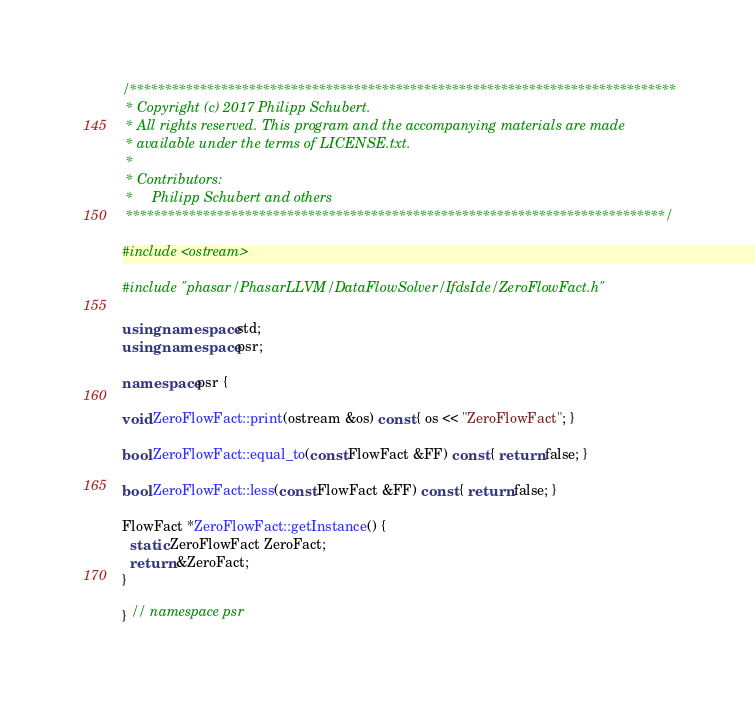Convert code to text. <code><loc_0><loc_0><loc_500><loc_500><_C++_>/******************************************************************************
 * Copyright (c) 2017 Philipp Schubert.
 * All rights reserved. This program and the accompanying materials are made
 * available under the terms of LICENSE.txt.
 *
 * Contributors:
 *     Philipp Schubert and others
 *****************************************************************************/

#include <ostream>

#include "phasar/PhasarLLVM/DataFlowSolver/IfdsIde/ZeroFlowFact.h"

using namespace std;
using namespace psr;

namespace psr {

void ZeroFlowFact::print(ostream &os) const { os << "ZeroFlowFact"; }

bool ZeroFlowFact::equal_to(const FlowFact &FF) const { return false; }

bool ZeroFlowFact::less(const FlowFact &FF) const { return false; }

FlowFact *ZeroFlowFact::getInstance() {
  static ZeroFlowFact ZeroFact;
  return &ZeroFact;
}

} // namespace psr
</code> 